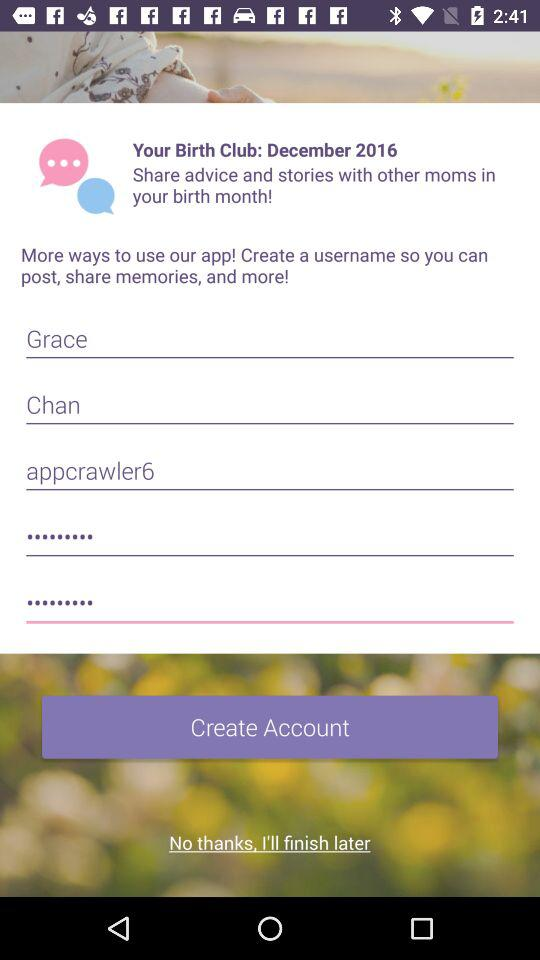What is "Your Birth Club"? "Your Birth Club" is December 2016. 